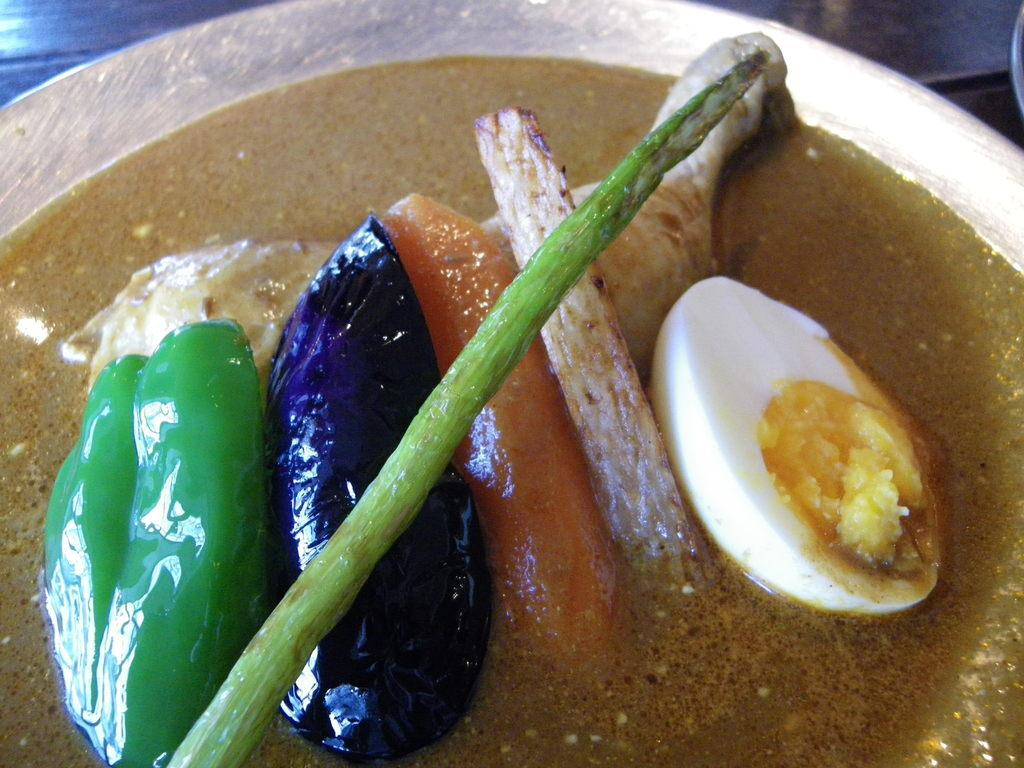What is placed in a plate in the image? There are eatable items placed in a plate in the image. Can you describe the eatable items in the plate? Unfortunately, the specific type of eatable items cannot be determined from the provided facts. Is there any utensil or tool placed with the plate? The provided facts do not mention any utensil or tool placed with the plate. What type of doctor is present in the image? There is no doctor present in the image; it features a plate with eatable items. What type of support can be seen in the image? There is no support present in the image; it features a plate with eatable items. 